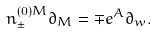<formula> <loc_0><loc_0><loc_500><loc_500>n _ { \pm } ^ { ( 0 ) M } \partial _ { M } = \mp e ^ { A } \partial _ { w } .</formula> 